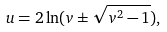Convert formula to latex. <formula><loc_0><loc_0><loc_500><loc_500>u = 2 \ln ( v \pm \sqrt { v ^ { 2 } - 1 } ) ,</formula> 